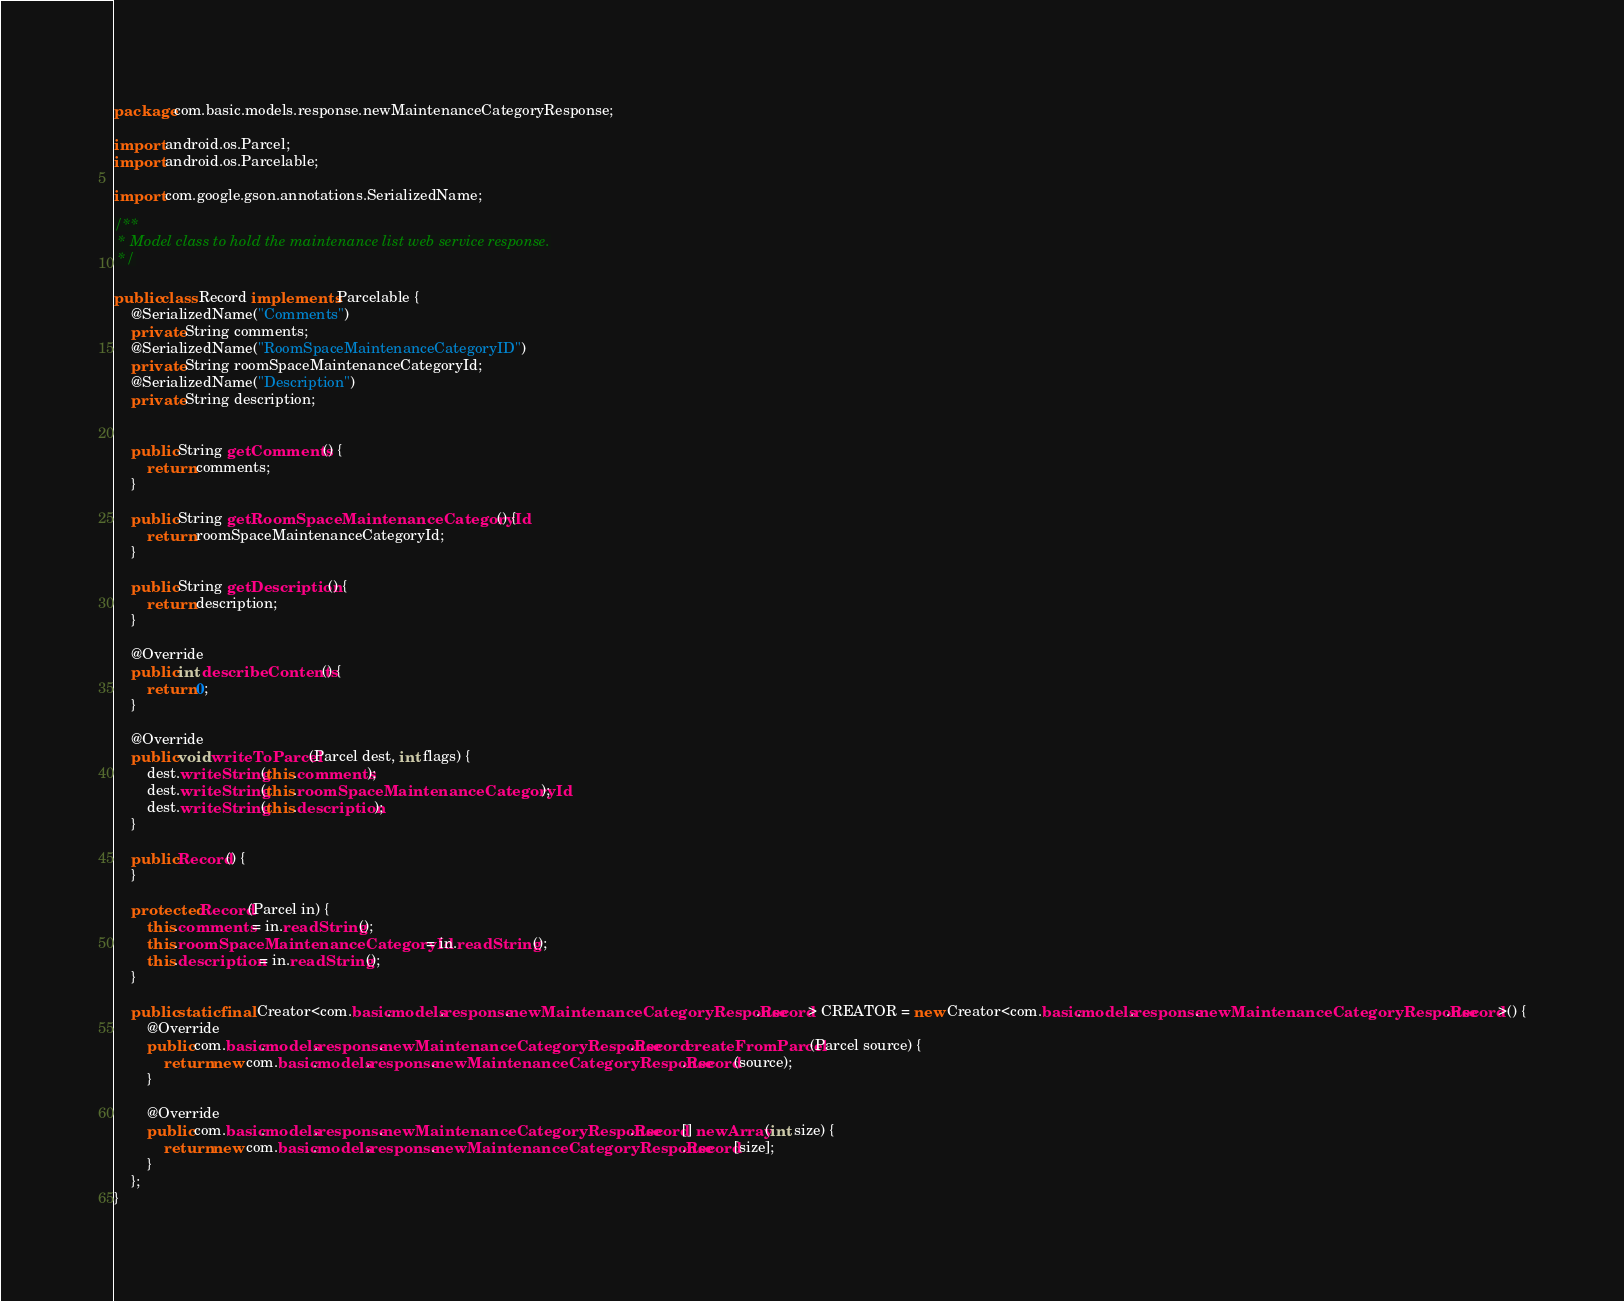Convert code to text. <code><loc_0><loc_0><loc_500><loc_500><_Java_>package com.basic.models.response.newMaintenanceCategoryResponse;

import android.os.Parcel;
import android.os.Parcelable;

import com.google.gson.annotations.SerializedName;

/**
 * Model class to hold the maintenance list web service response.
 */

public class Record implements Parcelable {
    @SerializedName("Comments")
    private String comments;
    @SerializedName("RoomSpaceMaintenanceCategoryID")
    private String roomSpaceMaintenanceCategoryId;
    @SerializedName("Description")
    private String description;


    public String getComments() {
        return comments;
    }

    public String getRoomSpaceMaintenanceCategoryId() {
        return roomSpaceMaintenanceCategoryId;
    }

    public String getDescription() {
        return description;
    }

    @Override
    public int describeContents() {
        return 0;
    }

    @Override
    public void writeToParcel(Parcel dest, int flags) {
        dest.writeString(this.comments);
        dest.writeString(this.roomSpaceMaintenanceCategoryId);
        dest.writeString(this.description);
    }

    public Record() {
    }

    protected Record(Parcel in) {
        this.comments = in.readString();
        this.roomSpaceMaintenanceCategoryId = in.readString();
        this.description = in.readString();
    }

    public static final Creator<com.basic.models.response.newMaintenanceCategoryResponse.Record> CREATOR = new Creator<com.basic.models.response.newMaintenanceCategoryResponse.Record>() {
        @Override
        public com.basic.models.response.newMaintenanceCategoryResponse.Record createFromParcel(Parcel source) {
            return new com.basic.models.response.newMaintenanceCategoryResponse.Record(source);
        }

        @Override
        public com.basic.models.response.newMaintenanceCategoryResponse.Record[] newArray(int size) {
            return new com.basic.models.response.newMaintenanceCategoryResponse.Record[size];
        }
    };
}
</code> 